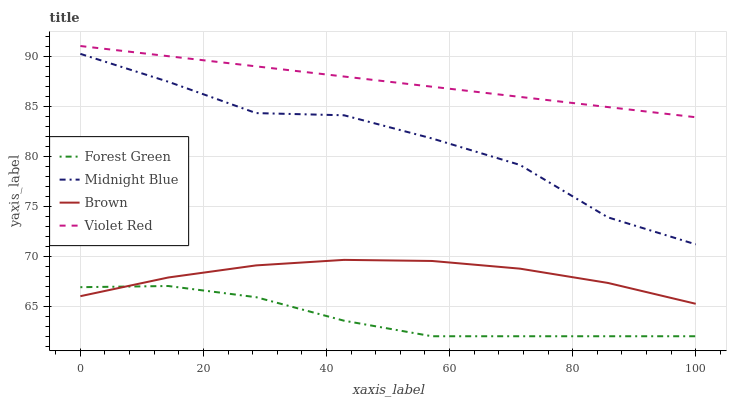Does Forest Green have the minimum area under the curve?
Answer yes or no. Yes. Does Violet Red have the maximum area under the curve?
Answer yes or no. Yes. Does Midnight Blue have the minimum area under the curve?
Answer yes or no. No. Does Midnight Blue have the maximum area under the curve?
Answer yes or no. No. Is Violet Red the smoothest?
Answer yes or no. Yes. Is Midnight Blue the roughest?
Answer yes or no. Yes. Is Forest Green the smoothest?
Answer yes or no. No. Is Forest Green the roughest?
Answer yes or no. No. Does Midnight Blue have the lowest value?
Answer yes or no. No. Does Violet Red have the highest value?
Answer yes or no. Yes. Does Midnight Blue have the highest value?
Answer yes or no. No. Is Forest Green less than Violet Red?
Answer yes or no. Yes. Is Midnight Blue greater than Brown?
Answer yes or no. Yes. Does Forest Green intersect Brown?
Answer yes or no. Yes. Is Forest Green less than Brown?
Answer yes or no. No. Is Forest Green greater than Brown?
Answer yes or no. No. Does Forest Green intersect Violet Red?
Answer yes or no. No. 